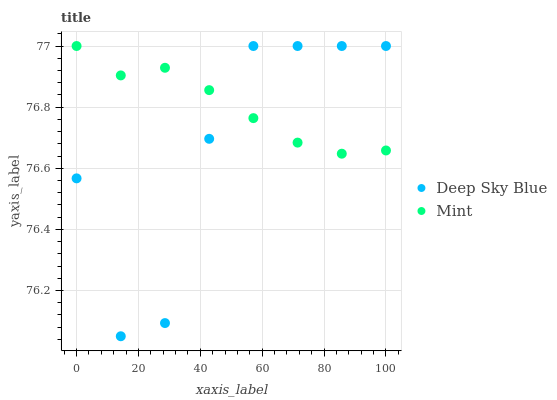Does Deep Sky Blue have the minimum area under the curve?
Answer yes or no. Yes. Does Mint have the maximum area under the curve?
Answer yes or no. Yes. Does Deep Sky Blue have the maximum area under the curve?
Answer yes or no. No. Is Mint the smoothest?
Answer yes or no. Yes. Is Deep Sky Blue the roughest?
Answer yes or no. Yes. Is Deep Sky Blue the smoothest?
Answer yes or no. No. Does Deep Sky Blue have the lowest value?
Answer yes or no. Yes. Does Deep Sky Blue have the highest value?
Answer yes or no. Yes. Does Deep Sky Blue intersect Mint?
Answer yes or no. Yes. Is Deep Sky Blue less than Mint?
Answer yes or no. No. Is Deep Sky Blue greater than Mint?
Answer yes or no. No. 